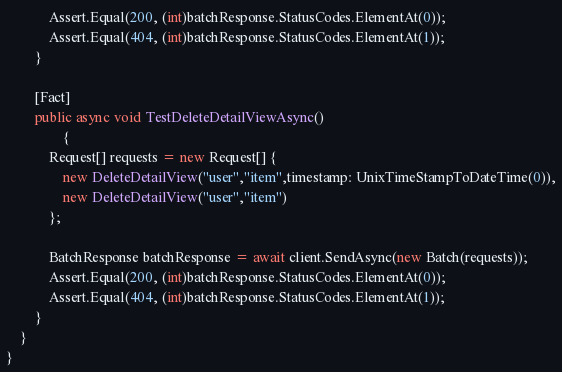<code> <loc_0><loc_0><loc_500><loc_500><_C#_>            Assert.Equal(200, (int)batchResponse.StatusCodes.ElementAt(0));
            Assert.Equal(404, (int)batchResponse.StatusCodes.ElementAt(1));
        }

        [Fact]
        public async void TestDeleteDetailViewAsync()
                {
            Request[] requests = new Request[] {
                new DeleteDetailView("user","item",timestamp: UnixTimeStampToDateTime(0)),
                new DeleteDetailView("user","item")
            };
        
            BatchResponse batchResponse = await client.SendAsync(new Batch(requests));
            Assert.Equal(200, (int)batchResponse.StatusCodes.ElementAt(0));
            Assert.Equal(404, (int)batchResponse.StatusCodes.ElementAt(1));
        }
    }
}
</code> 